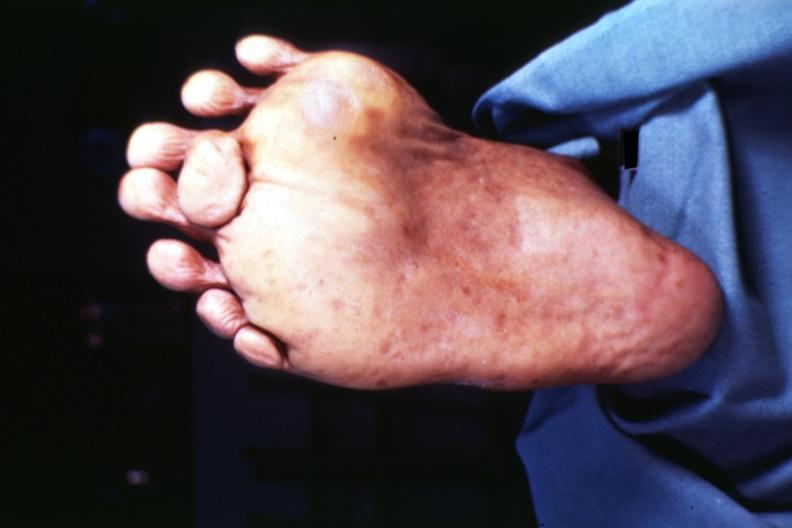what is present?
Answer the question using a single word or phrase. Supernumerary digits 